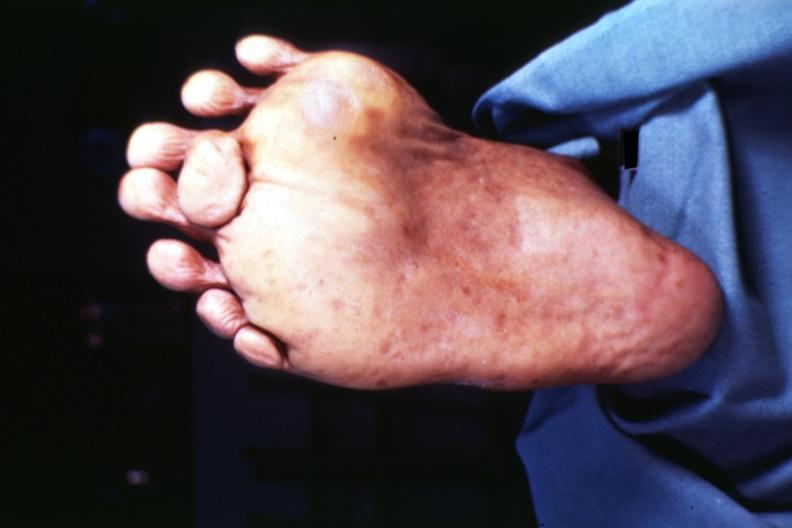what is present?
Answer the question using a single word or phrase. Supernumerary digits 